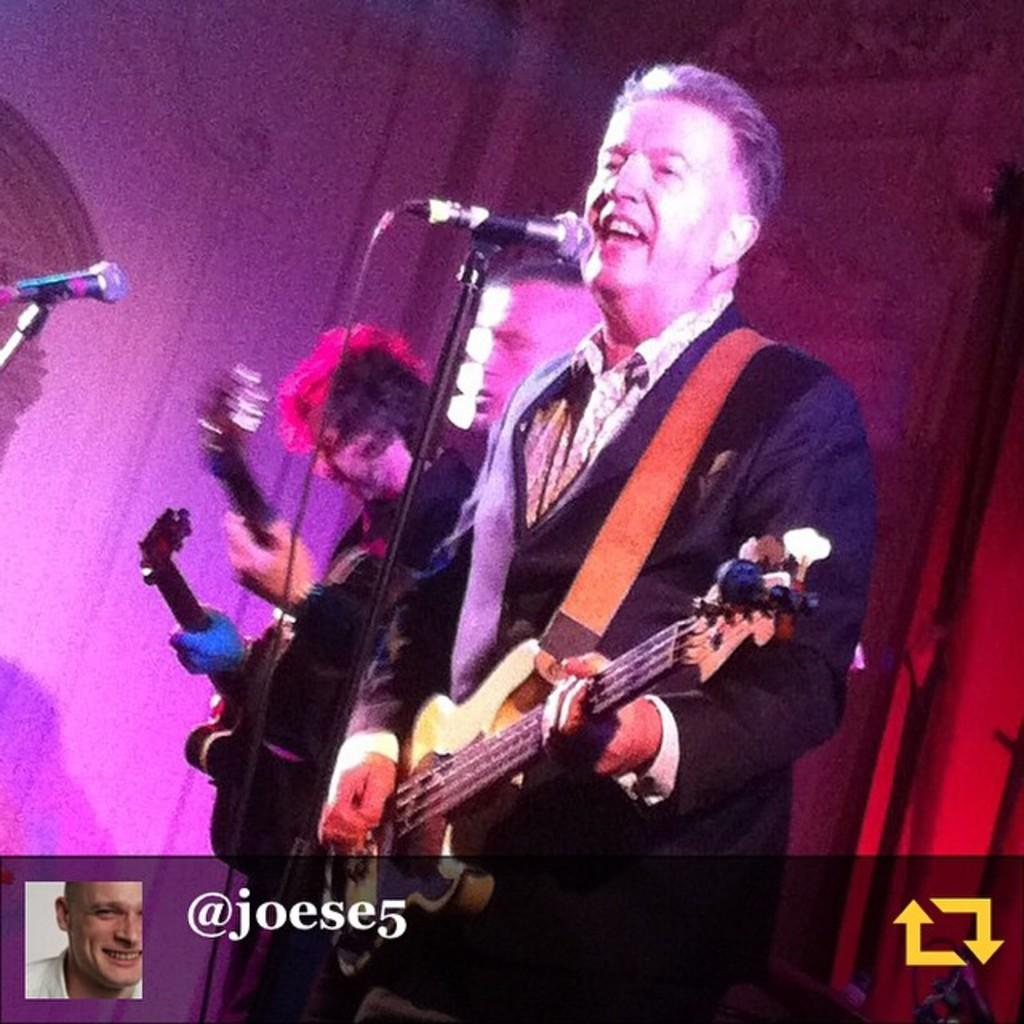What is the main subject of the image? The main subject of the image is a man. What is the man doing in the image? The man is standing, singing, and holding a guitar in his hands. What object is the man using while singing? The man is using a microphone. What type of chicken can be seen playing the guitar in the image? There is no chicken, let alone one playing the guitar, present in the image. Can you tell me how many dinosaurs are visible in the image? There are no dinosaurs present in the image. How many women are visible in the image? There is no mention of any women in the image; it features a man. 